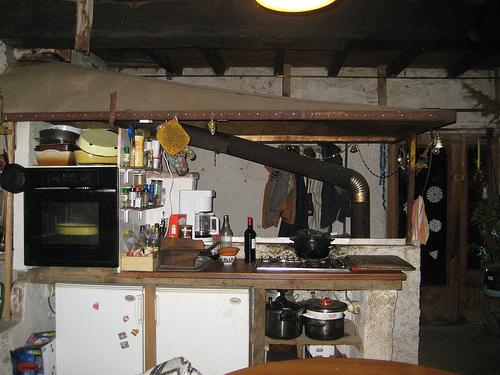What are some interesting aspects of the kitchen displayed in the image? The kitchen has a black oven with a yellow pan inside, a white coffee maker with coffee pot, and pots under a cabinet, as well as on top of the microwave. Provide a brief statement about the primary focus of the image. The image shows a kitchen scene with various items such as pots, microwave, coffee maker, and some jackets hanging on the wall. Mention few objects that you notice upon first glance at the image. A pot on the burner, jackets hanging from the wall, a white coffee maker, and a black microwave oven are noticeable in the image. In a narrative form, describe the image while focusing on the most prominent components. In the image, the kitchen bustles with various items strewn about. Pots are everywhere—on the stove, under the cabinet, and atop the microwave. Jackets hang on the wall, and a coffee maker rests on the counter. Describe the overall atmosphere of the kitchen in the image, taking into account what the objects might convey about the owner. The kitchen appears to be a busy and somewhat cluttered space, with various objects such as pots, jackets, and bottles suggesting the owner utilizes the kitchen extensively for various purposes. Provide a concise description of the key features in the image, emphasizing the style and function of the kitchen. The image exhibits a functional yet cluttered kitchen space with multiple pots, a stove, microwave, coffee maker, and jackets hanging on the wall. Identify some key elements present in the image that demonstrates a sense of clutter or organization. Cluttered elements include the hanging jackets, assorted pots and pans in different places, and the bottles on the counter, while the white fridges side by side show organization. Describe the organization or arrangement of the pots in the kitchen. There are pots on the stove, pots under the cabinet, and pots on top of the microwave; some of them are even stacked on a shelf. 